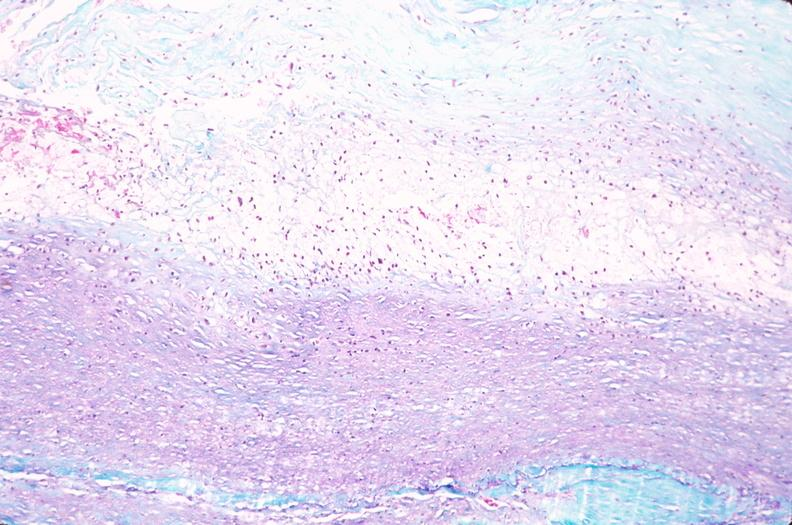where is this in?
Answer the question using a single word or phrase. In vasculature 